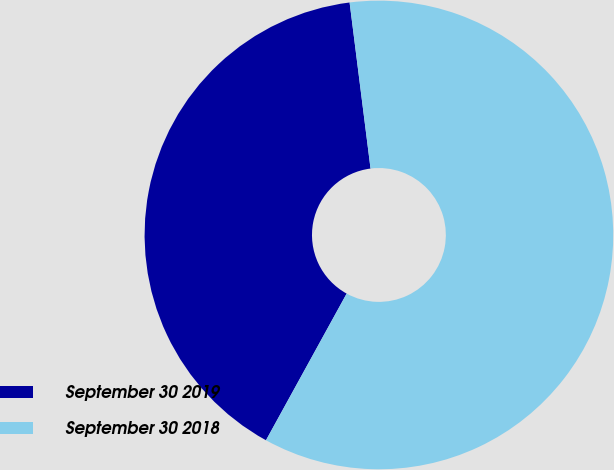<chart> <loc_0><loc_0><loc_500><loc_500><pie_chart><fcel>September 30 2019<fcel>September 30 2018<nl><fcel>40.0%<fcel>60.0%<nl></chart> 